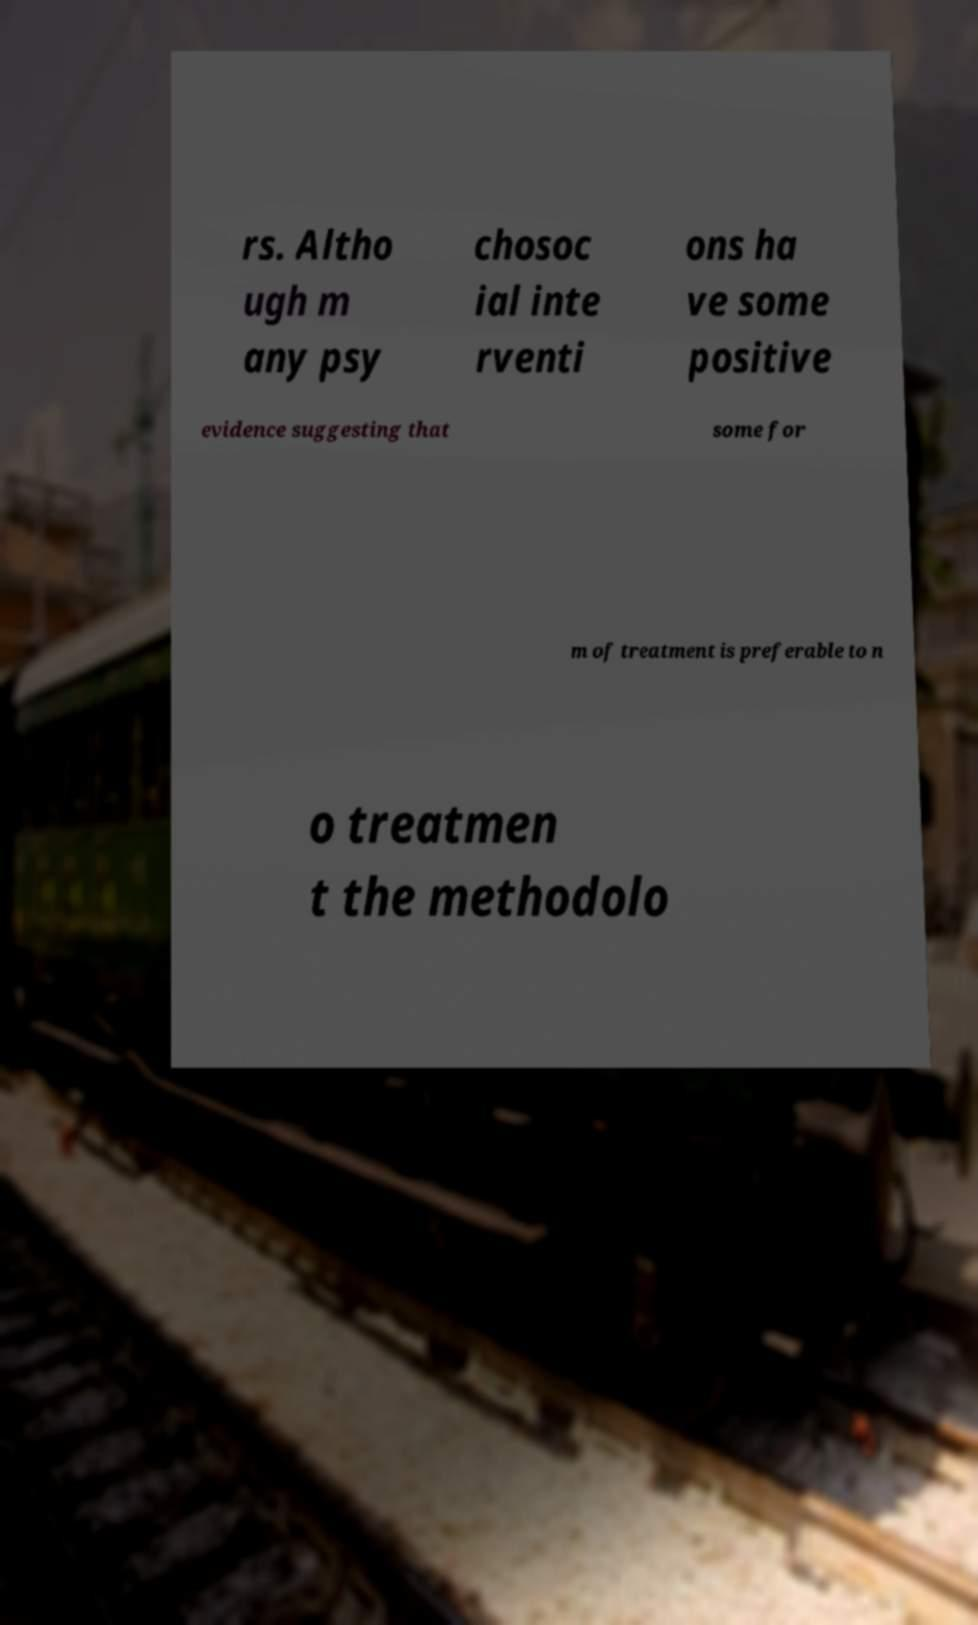Could you extract and type out the text from this image? rs. Altho ugh m any psy chosoc ial inte rventi ons ha ve some positive evidence suggesting that some for m of treatment is preferable to n o treatmen t the methodolo 